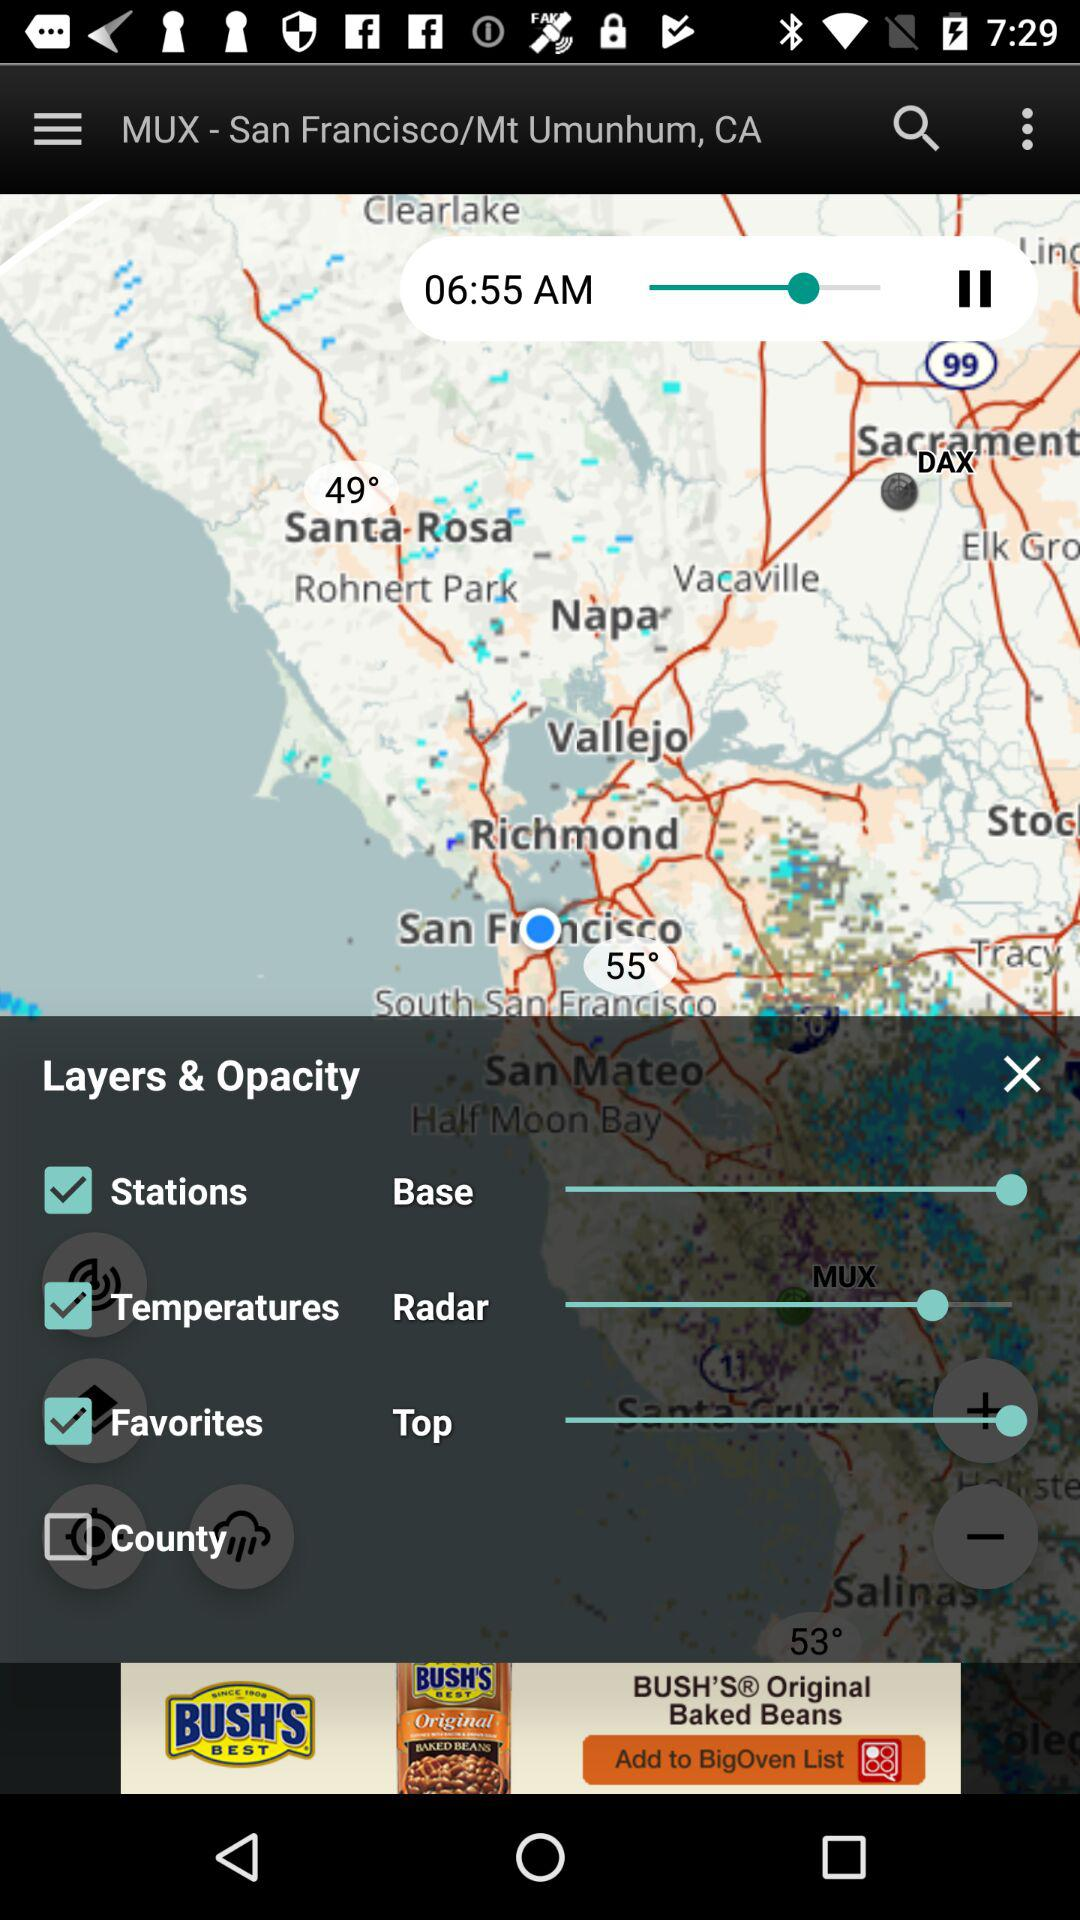What is the status of "County"? The status is "off". 